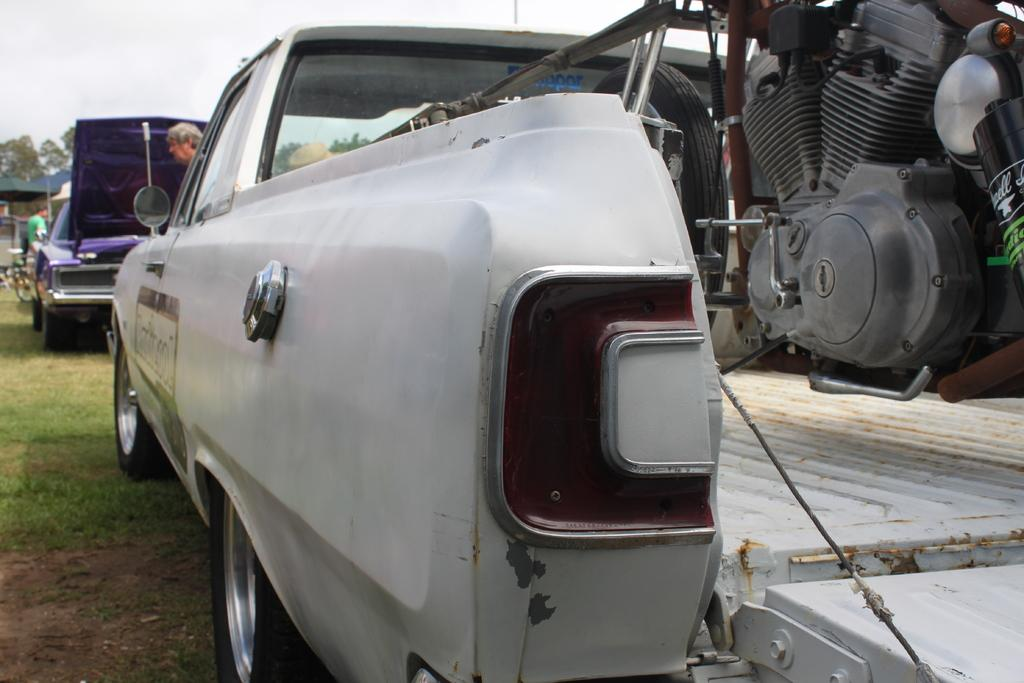What is the main subject in the foreground of the image? There is a bike in a van in the foreground of the image. What can be seen in the background of the image? In the background of the image, there is a purple car, a man, trees, tents, a bicycle, grass, and the sky. How many vehicles are visible in the image? There are two vehicles visible in the image: a van in the foreground and a purple car in the background. What type of terrain is visible in the background of the image? The background of the image shows grass, which suggests a grassy or park-like terrain. What type of straw is being used for pleasure in the image? There is no straw or indication of pleasure in the image; it features a bike in a van and various background elements. 